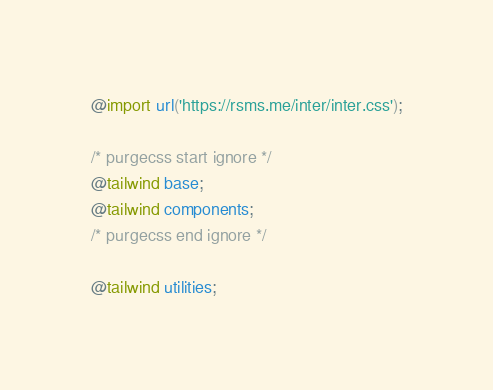<code> <loc_0><loc_0><loc_500><loc_500><_CSS_>@import url('https://rsms.me/inter/inter.css');

/* purgecss start ignore */
@tailwind base;
@tailwind components;
/* purgecss end ignore */

@tailwind utilities;</code> 